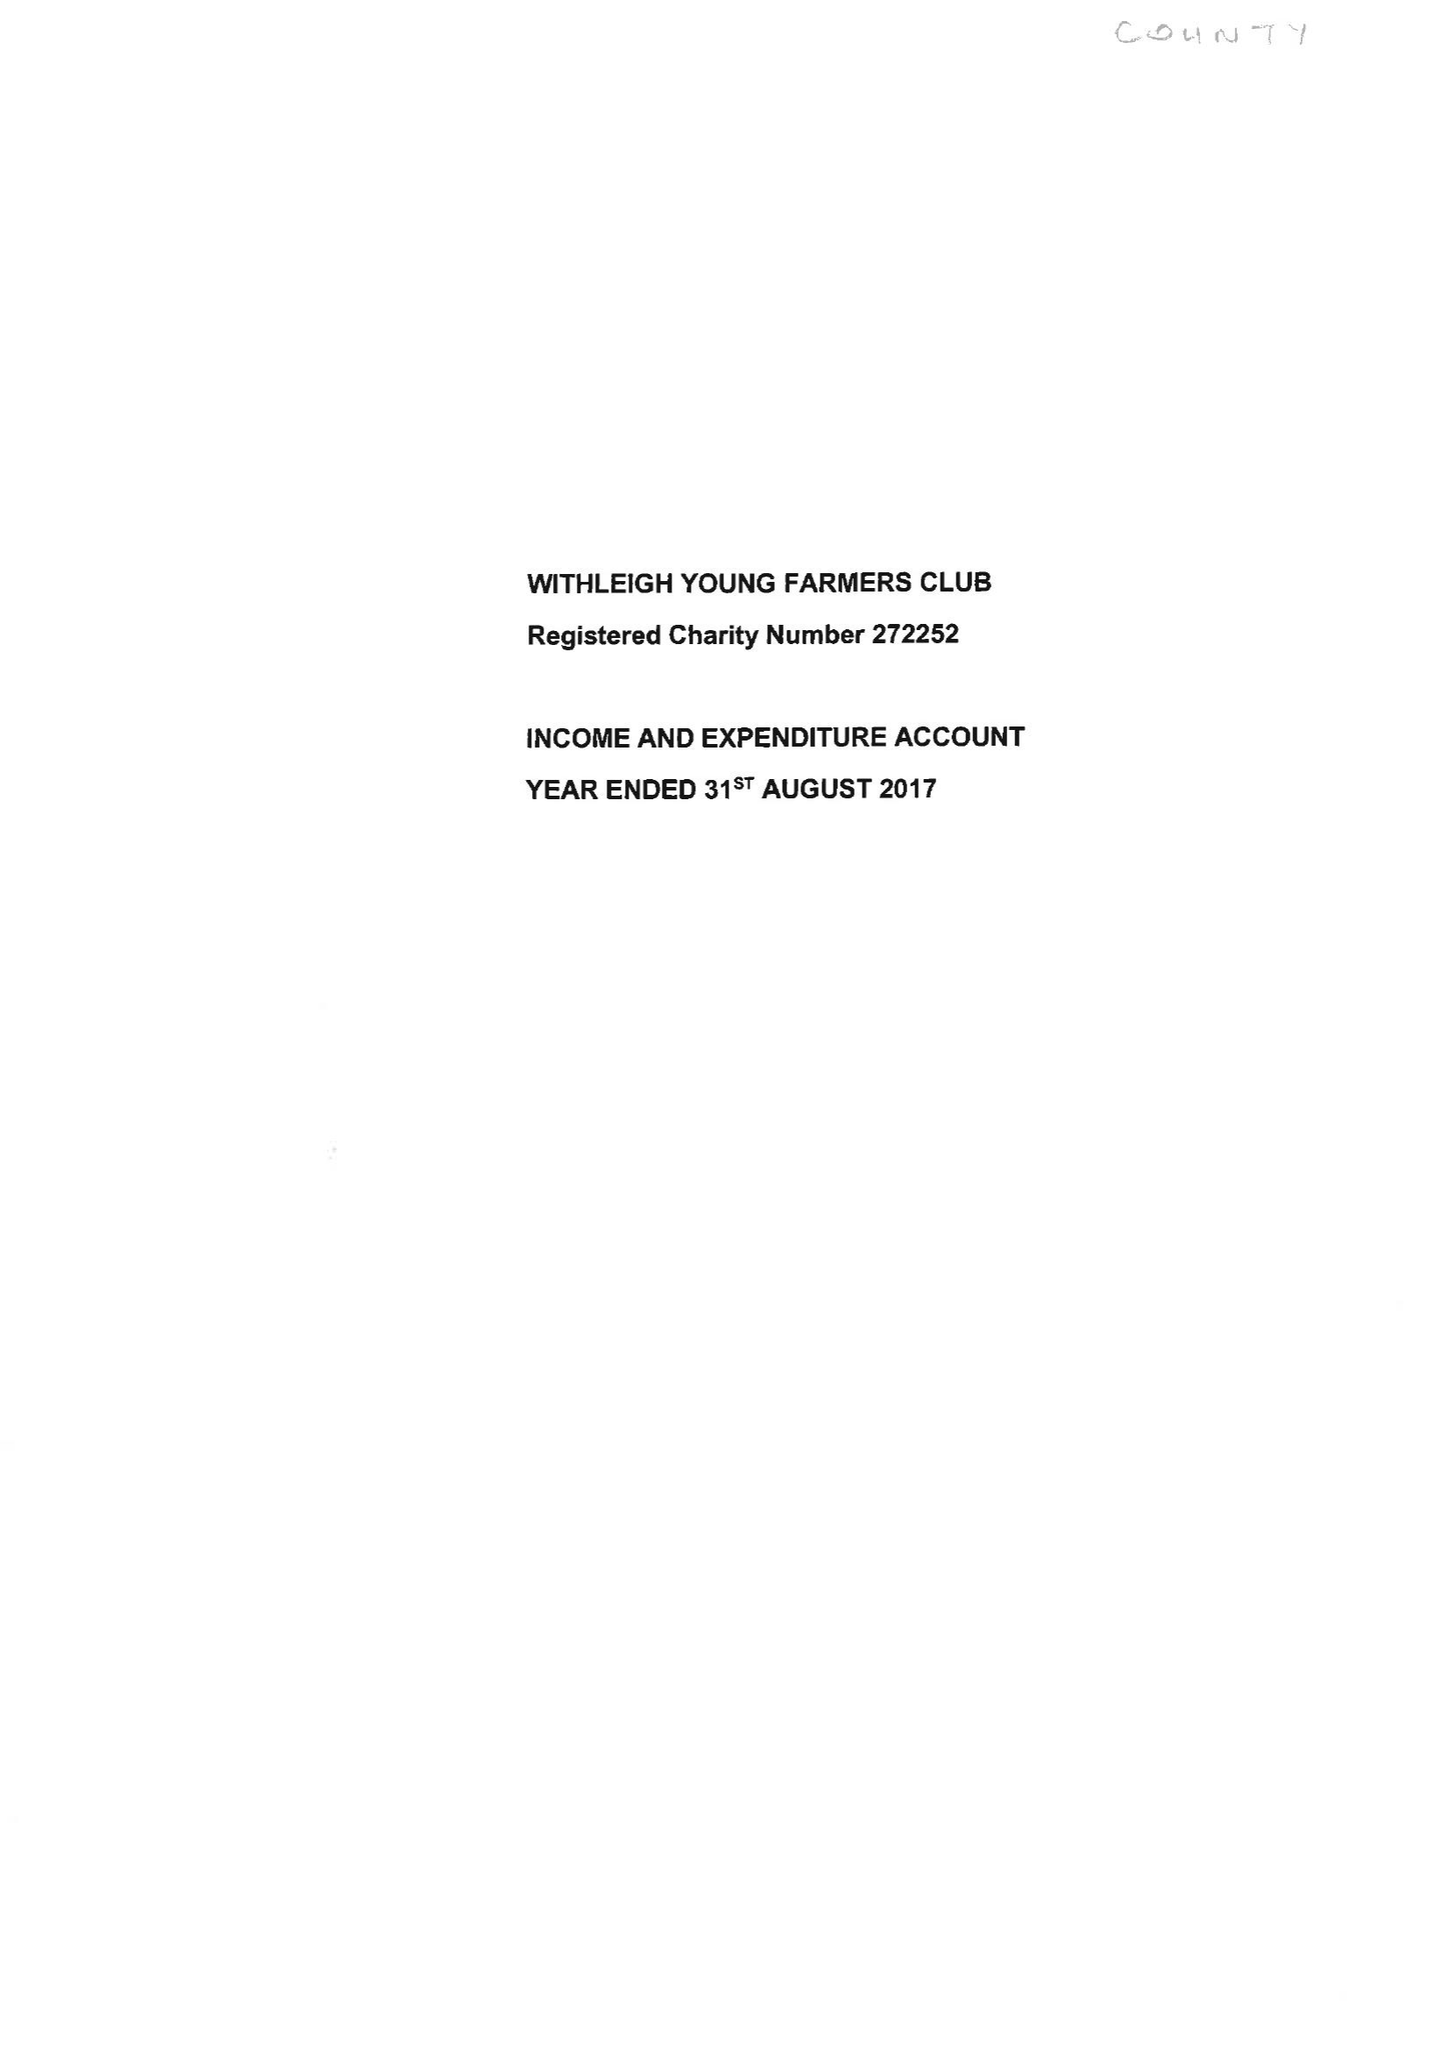What is the value for the spending_annually_in_british_pounds?
Answer the question using a single word or phrase. 26888.00 